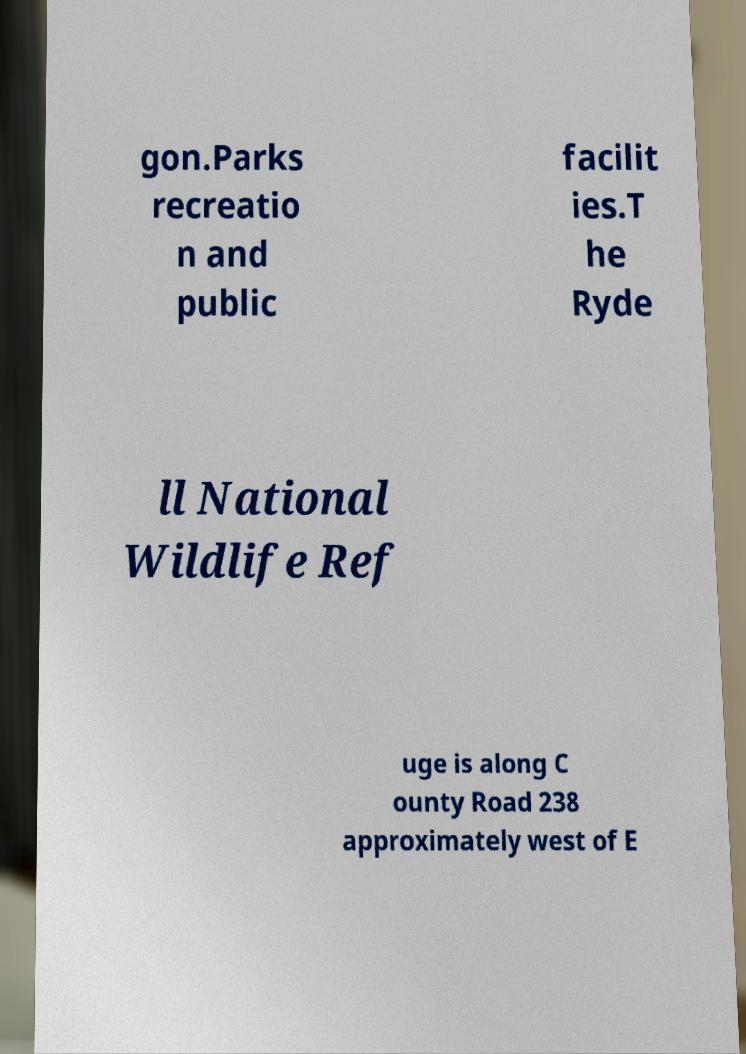Can you read and provide the text displayed in the image?This photo seems to have some interesting text. Can you extract and type it out for me? gon.Parks recreatio n and public facilit ies.T he Ryde ll National Wildlife Ref uge is along C ounty Road 238 approximately west of E 